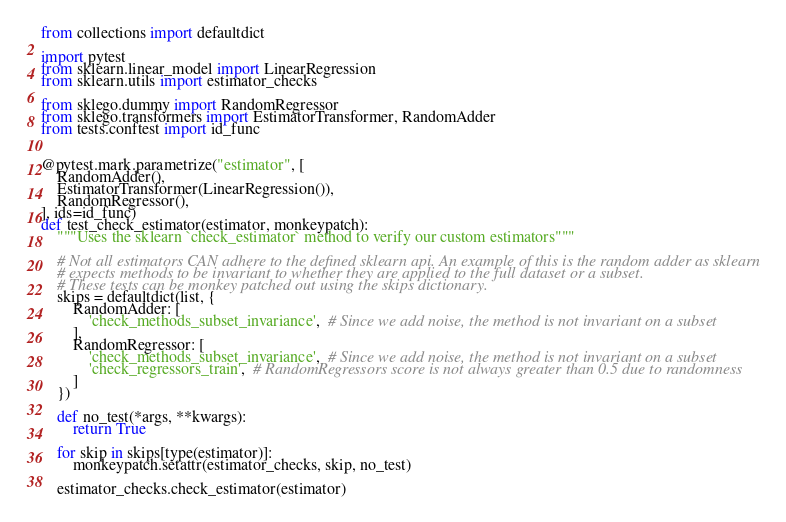Convert code to text. <code><loc_0><loc_0><loc_500><loc_500><_Python_>from collections import defaultdict

import pytest
from sklearn.linear_model import LinearRegression
from sklearn.utils import estimator_checks

from sklego.dummy import RandomRegressor
from sklego.transformers import EstimatorTransformer, RandomAdder
from tests.conftest import id_func


@pytest.mark.parametrize("estimator", [
    RandomAdder(),
    EstimatorTransformer(LinearRegression()),
    RandomRegressor(),
], ids=id_func)
def test_check_estimator(estimator, monkeypatch):
    """Uses the sklearn `check_estimator` method to verify our custom estimators"""

    # Not all estimators CAN adhere to the defined sklearn api. An example of this is the random adder as sklearn
    # expects methods to be invariant to whether they are applied to the full dataset or a subset.
    # These tests can be monkey patched out using the skips dictionary.
    skips = defaultdict(list, {
        RandomAdder: [
            'check_methods_subset_invariance',  # Since we add noise, the method is not invariant on a subset
        ],
        RandomRegressor: [
            'check_methods_subset_invariance',  # Since we add noise, the method is not invariant on a subset
            'check_regressors_train',  # RandomRegressors score is not always greater than 0.5 due to randomness
        ]
    })

    def no_test(*args, **kwargs):
        return True

    for skip in skips[type(estimator)]:
        monkeypatch.setattr(estimator_checks, skip, no_test)

    estimator_checks.check_estimator(estimator)
</code> 